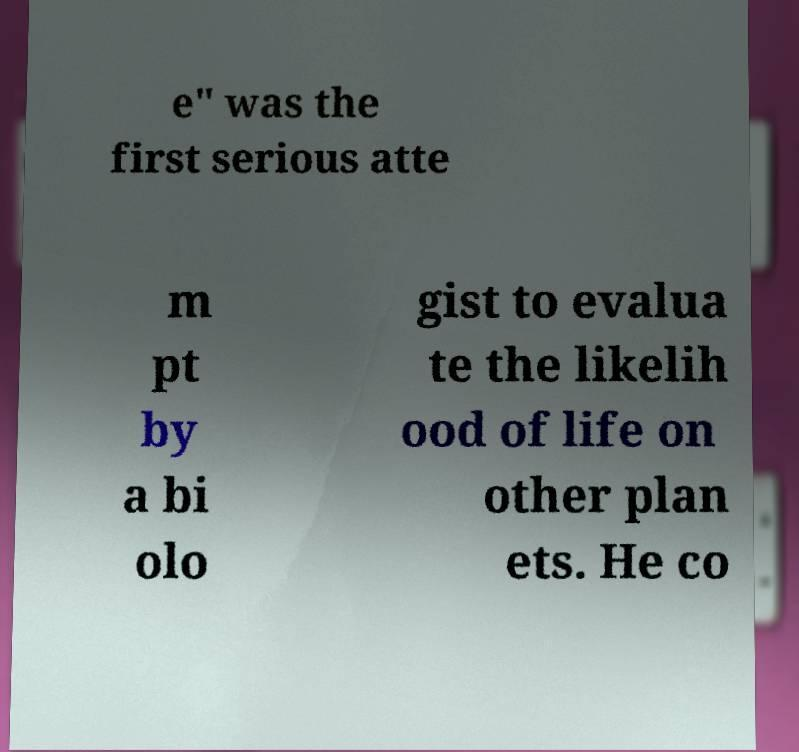I need the written content from this picture converted into text. Can you do that? e" was the first serious atte m pt by a bi olo gist to evalua te the likelih ood of life on other plan ets. He co 